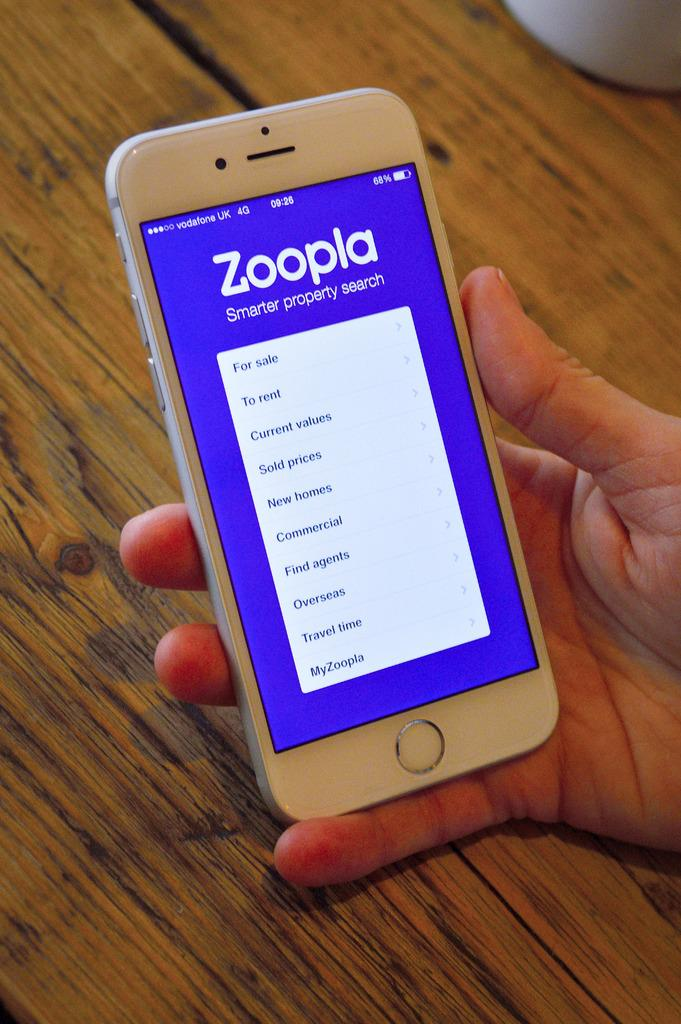<image>
Write a terse but informative summary of the picture. Someone holding a cellphone that has the Zoopla app loaded on it 